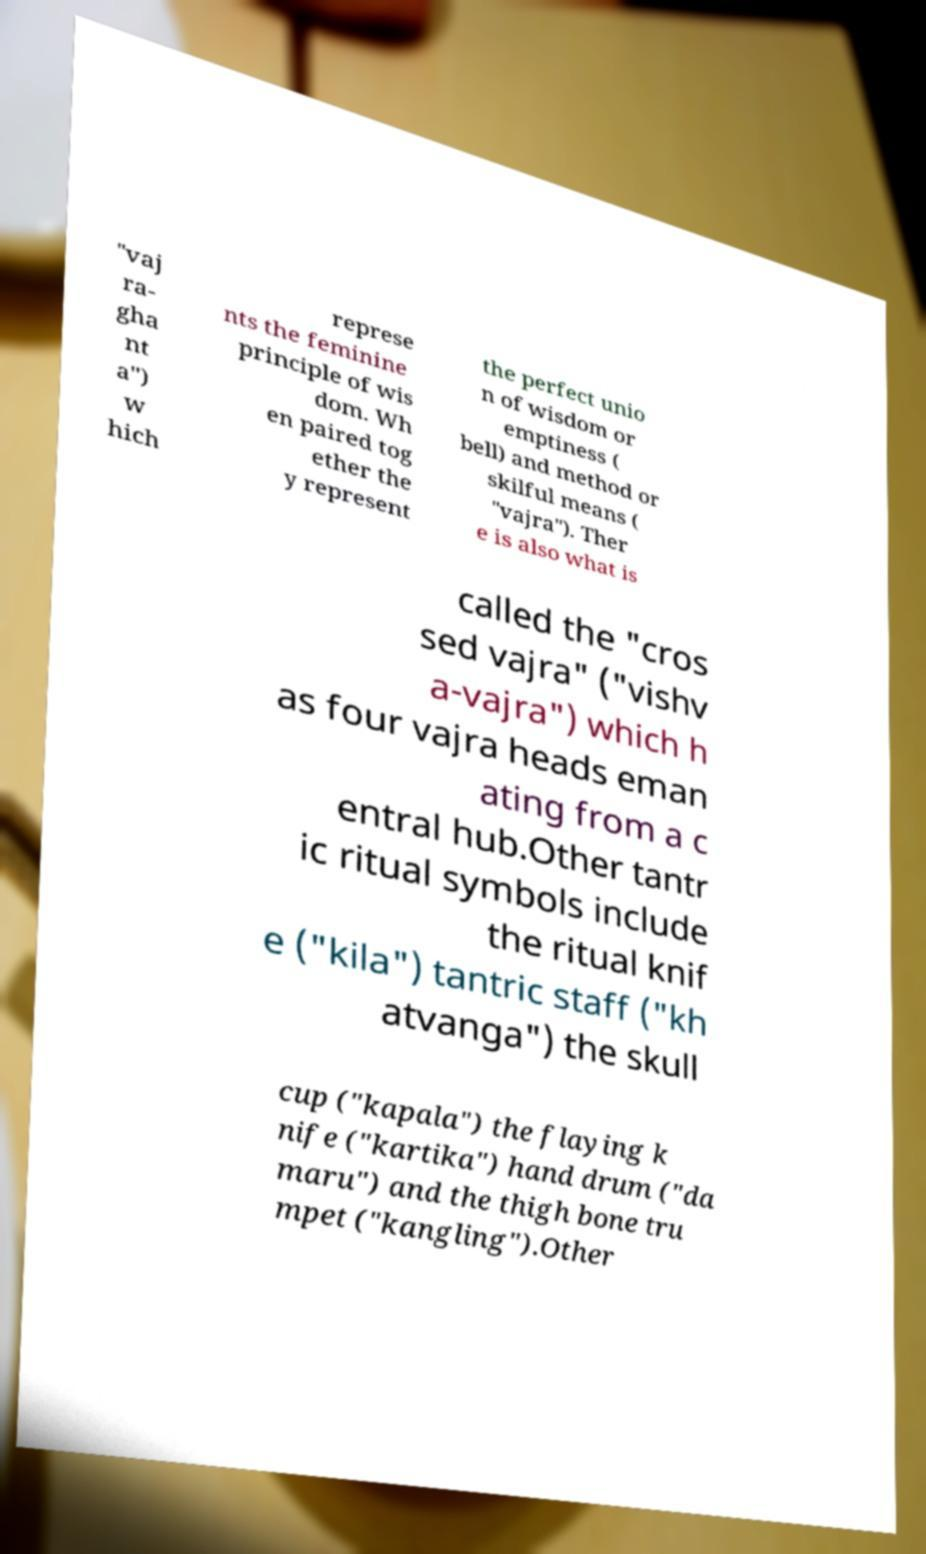What messages or text are displayed in this image? I need them in a readable, typed format. "vaj ra- gha nt a") w hich represe nts the feminine principle of wis dom. Wh en paired tog ether the y represent the perfect unio n of wisdom or emptiness ( bell) and method or skilful means ( "vajra"). Ther e is also what is called the "cros sed vajra" ("vishv a-vajra") which h as four vajra heads eman ating from a c entral hub.Other tantr ic ritual symbols include the ritual knif e ("kila") tantric staff ("kh atvanga") the skull cup ("kapala") the flaying k nife ("kartika") hand drum ("da maru") and the thigh bone tru mpet ("kangling").Other 